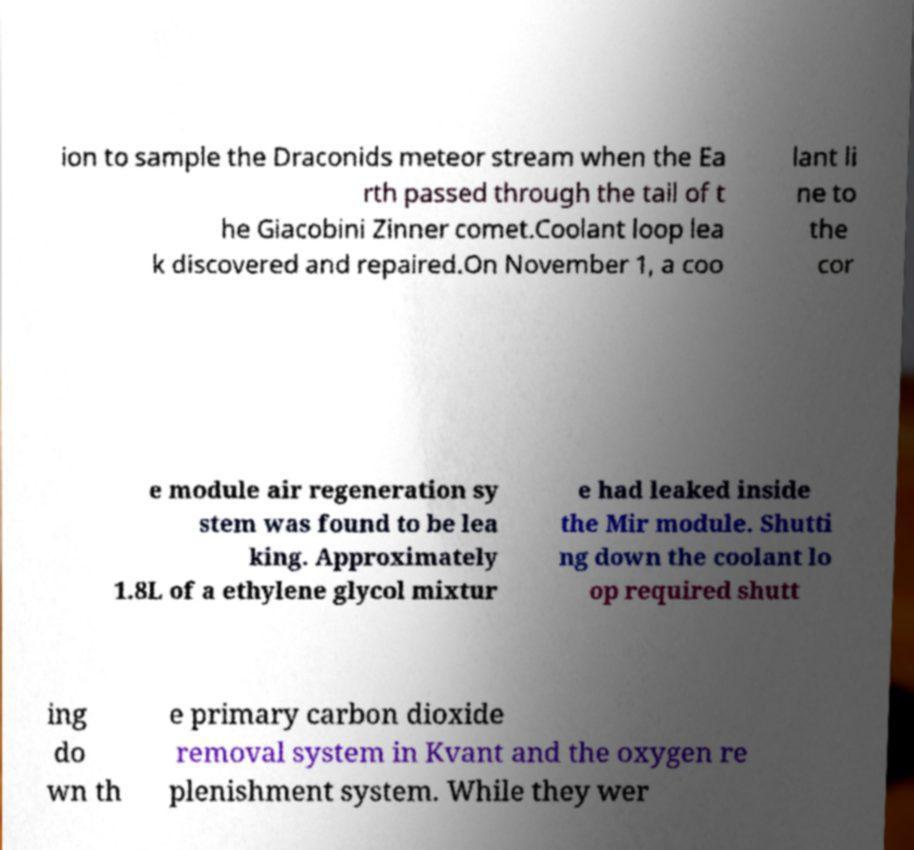Please identify and transcribe the text found in this image. ion to sample the Draconids meteor stream when the Ea rth passed through the tail of t he Giacobini Zinner comet.Coolant loop lea k discovered and repaired.On November 1, a coo lant li ne to the cor e module air regeneration sy stem was found to be lea king. Approximately 1.8L of a ethylene glycol mixtur e had leaked inside the Mir module. Shutti ng down the coolant lo op required shutt ing do wn th e primary carbon dioxide removal system in Kvant and the oxygen re plenishment system. While they wer 